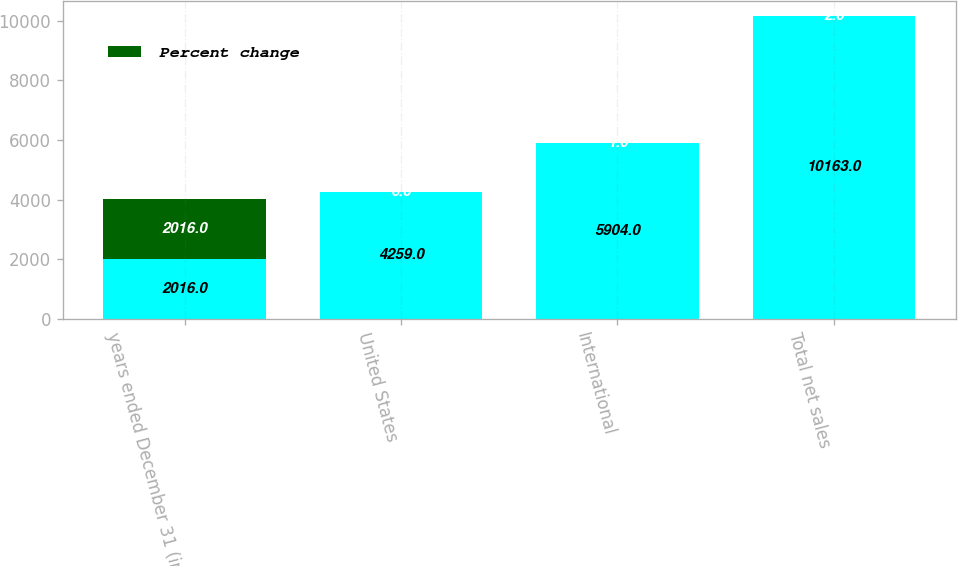Convert chart. <chart><loc_0><loc_0><loc_500><loc_500><stacked_bar_chart><ecel><fcel>years ended December 31 (in<fcel>United States<fcel>International<fcel>Total net sales<nl><fcel>nan<fcel>2016<fcel>4259<fcel>5904<fcel>10163<nl><fcel>Percent change<fcel>2016<fcel>6<fcel>1<fcel>2<nl></chart> 